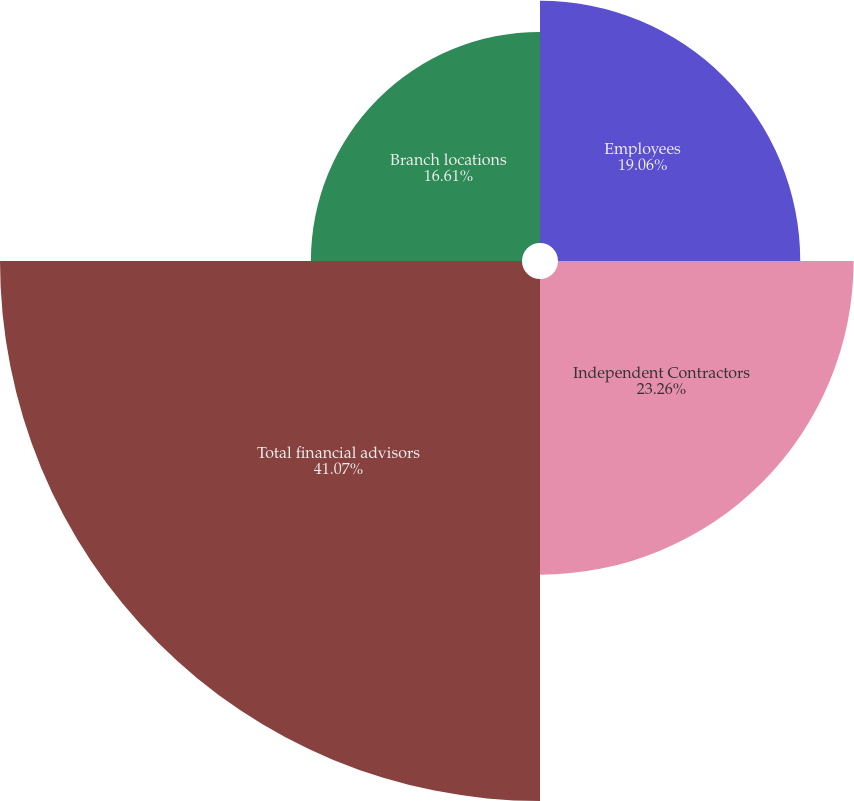Convert chart to OTSL. <chart><loc_0><loc_0><loc_500><loc_500><pie_chart><fcel>Employees<fcel>Independent Contractors<fcel>Total financial advisors<fcel>Branch locations<nl><fcel>19.06%<fcel>23.26%<fcel>41.07%<fcel>16.61%<nl></chart> 